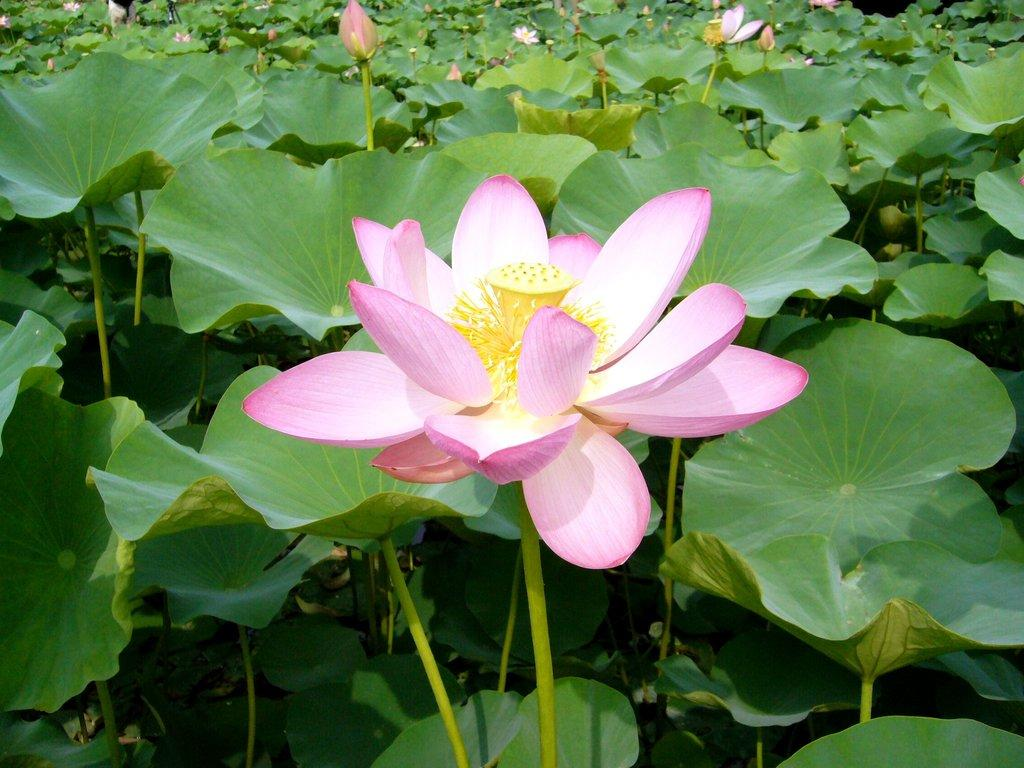What color are the flowers in the image? The flowers in the image are pink. What else can be seen in the image besides the flowers? Leaves and stems are present in the image. What type of vest is being worn by the leaf in the image? There is no leaf wearing a vest in the image, as leaves do not wear clothing. 